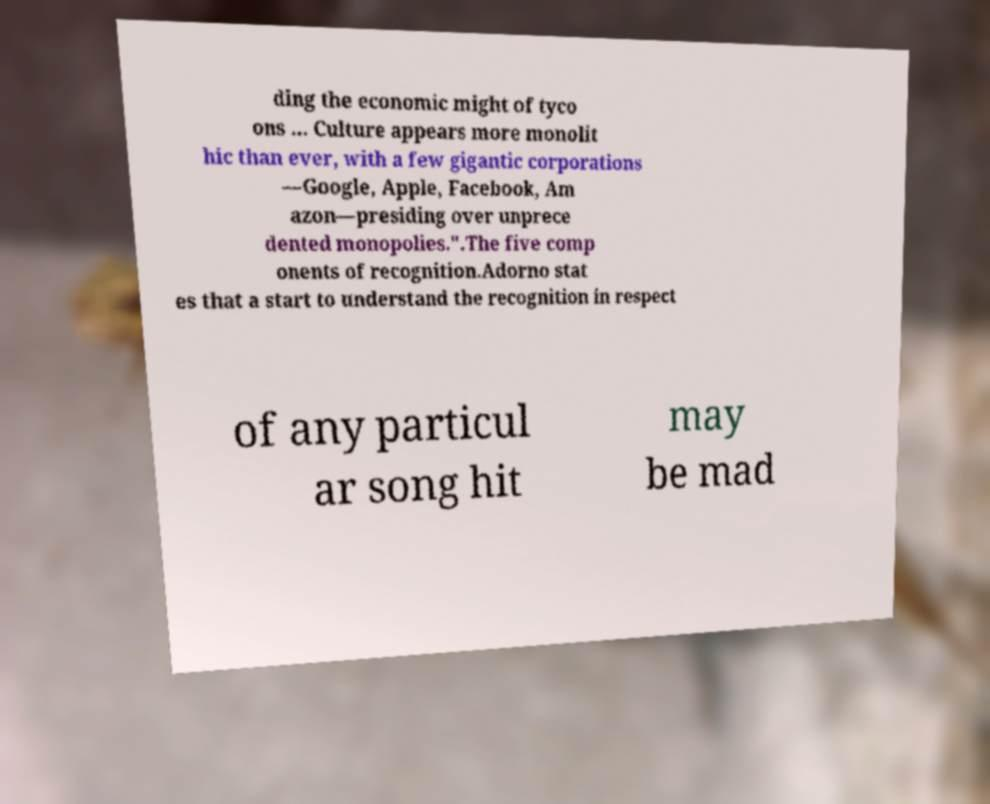Can you accurately transcribe the text from the provided image for me? ding the economic might of tyco ons ... Culture appears more monolit hic than ever, with a few gigantic corporations —Google, Apple, Facebook, Am azon—presiding over unprece dented monopolies.".The five comp onents of recognition.Adorno stat es that a start to understand the recognition in respect of any particul ar song hit may be mad 